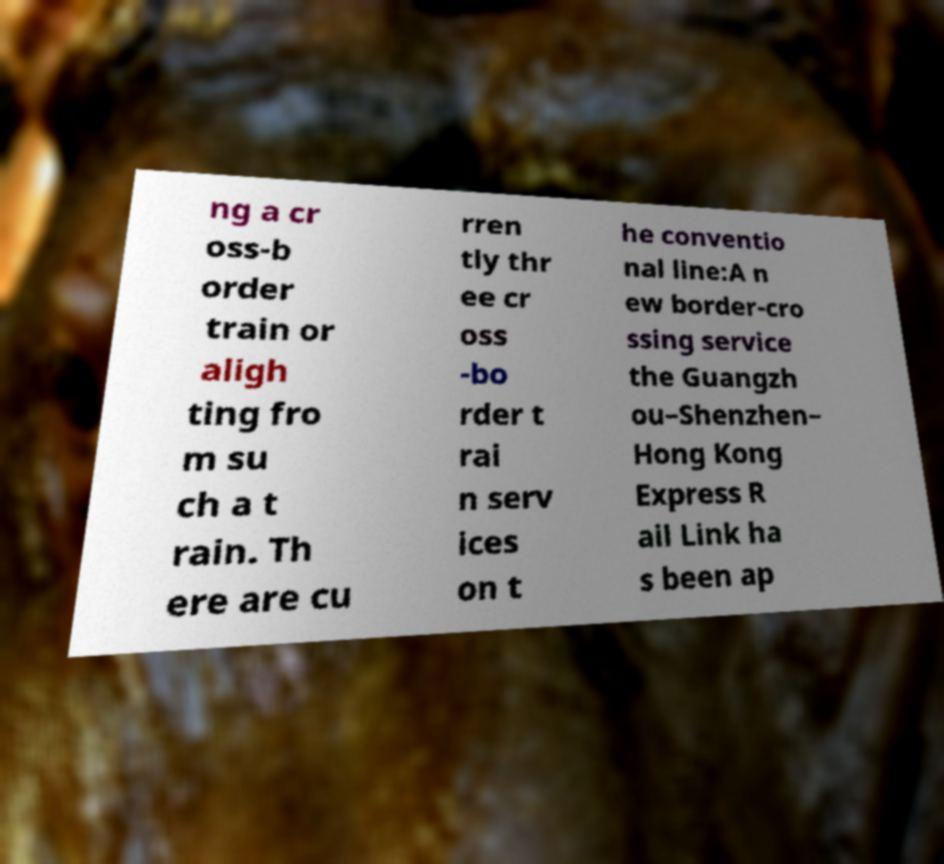What messages or text are displayed in this image? I need them in a readable, typed format. ng a cr oss-b order train or aligh ting fro m su ch a t rain. Th ere are cu rren tly thr ee cr oss -bo rder t rai n serv ices on t he conventio nal line:A n ew border-cro ssing service the Guangzh ou–Shenzhen– Hong Kong Express R ail Link ha s been ap 